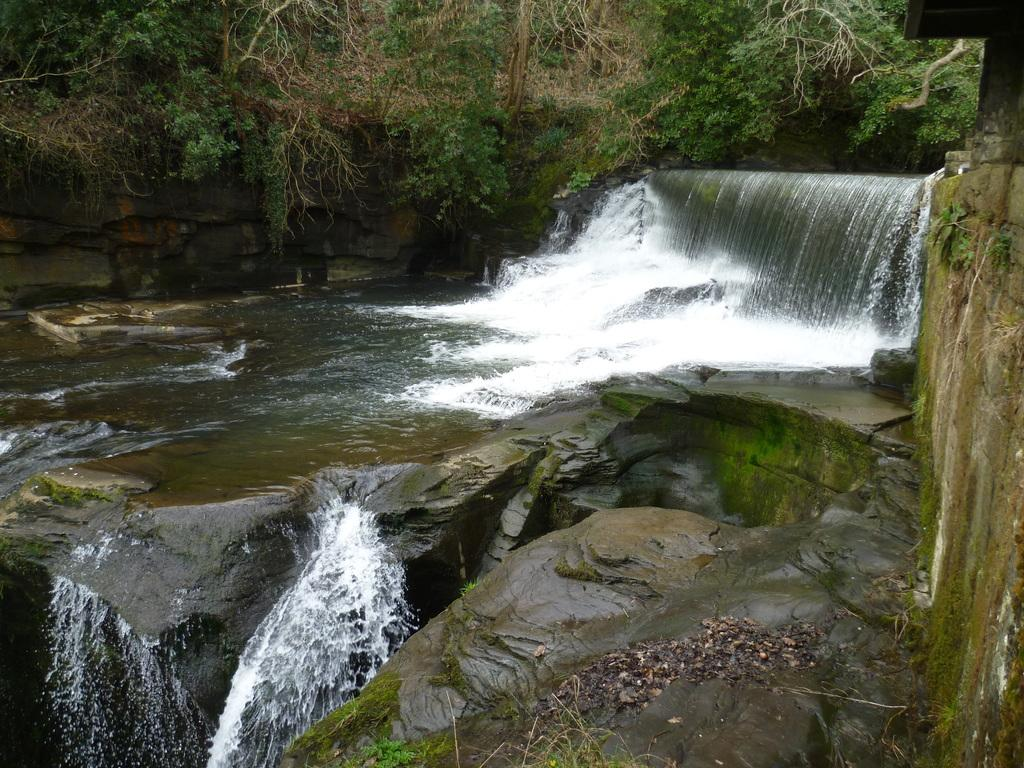Where was the picture taken? The picture was clicked outside the city. What can be seen in the foreground of the image? There is a water body and rocks in the foreground. What natural feature is present on the right side of the image? There is a waterfall on the right side. What type of vegetation can be seen in the background of the image? There are trees visible in the background. What type of stew is being prepared by the queen in the image? There is no queen or stew present in the image; it features a water body, rocks, a waterfall, and trees. 